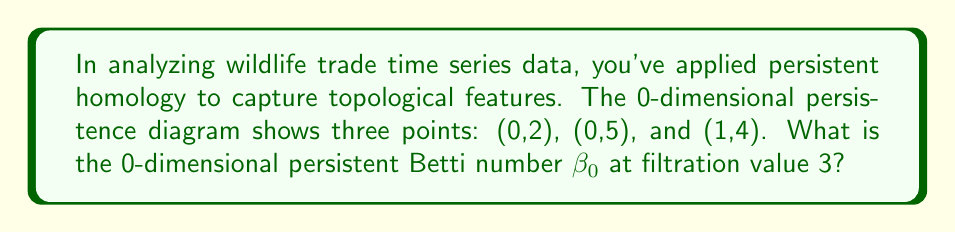Help me with this question. To solve this problem, we need to understand persistent homology and how to interpret a persistence diagram:

1) Persistent homology tracks topological features (e.g., connected components for 0-dimensional homology) across different scales or filtration values.

2) In a persistence diagram, each point (b,d) represents a topological feature that appears at birth time b and disappears at death time d.

3) The 0-dimensional persistent Betti number $\beta_0$ at a given filtration value t is the number of points in the diagram that:
   a) Have been born (b ≤ t)
   b) Have not yet died (d > t)

4) Given points: (0,2), (0,5), and (1,4)

5) At filtration value t = 3:
   - (0,2): Born at 0, died at 2. Not counted as 2 < 3.
   - (0,5): Born at 0, still alive as 5 > 3. Counted.
   - (1,4): Born at 1, still alive as 4 > 3. Counted.

6) Therefore, at t = 3, two points satisfy the conditions.

The persistent Betti number $\beta_0(3) = 2$.

This result indicates that at filtration value 3, the wildlife trade time series data exhibits two distinct connected components or clusters in its topological structure.
Answer: $\beta_0(3) = 2$ 